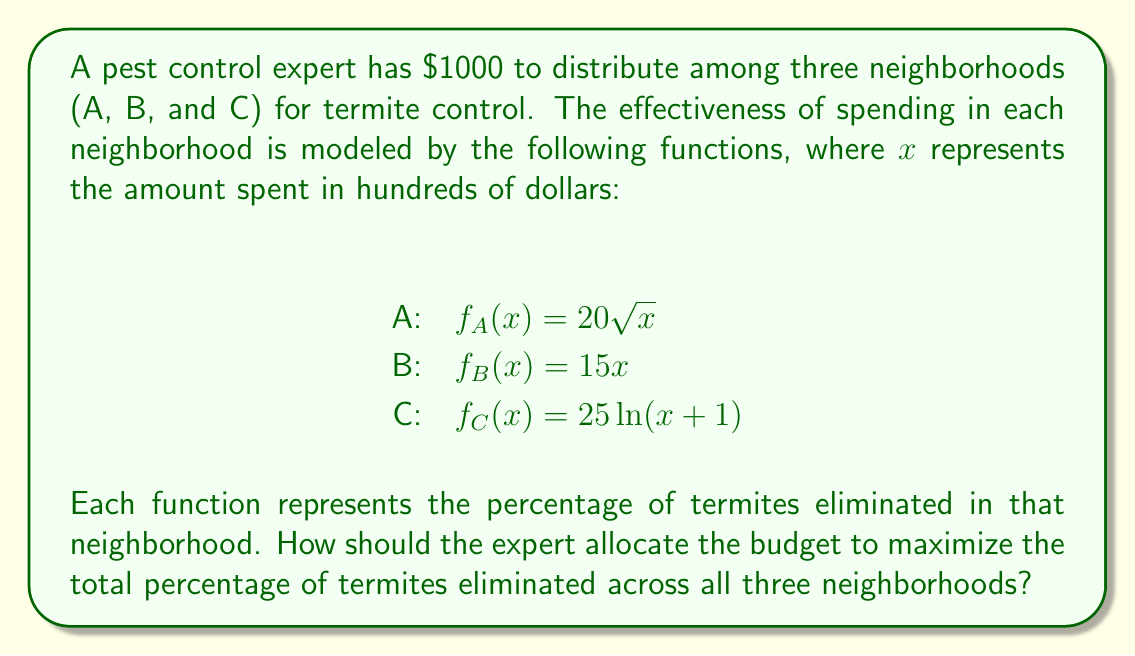Help me with this question. To solve this optimization problem, we need to use the method of Lagrange multipliers. Let's approach this step-by-step:

1) Let $x$, $y$, and $z$ represent the amount spent (in hundreds of dollars) in neighborhoods A, B, and C respectively.

2) Our objective function is:
   $$F(x,y,z) = 20\sqrt{x} + 15y + 25\ln(z+1)$$

3) Our constraint is:
   $$x + y + z = 10$$ (since the total budget is $1000 = 10 * $100)

4) We form the Lagrangian:
   $$L(x,y,z,\lambda) = 20\sqrt{x} + 15y + 25\ln(z+1) - \lambda(x + y + z - 10)$$

5) We now take partial derivatives and set them equal to zero:

   $$\frac{\partial L}{\partial x} = \frac{10}{\sqrt{x}} - \lambda = 0$$
   $$\frac{\partial L}{\partial y} = 15 - \lambda = 0$$
   $$\frac{\partial L}{\partial z} = \frac{25}{z+1} - \lambda = 0$$
   $$\frac{\partial L}{\partial \lambda} = x + y + z - 10 = 0$$

6) From these equations, we can deduce:

   $$\frac{10}{\sqrt{x}} = 15 = \frac{25}{z+1}$$

7) Solving these:
   $$x = (\frac{10}{15})^2 = \frac{4}{9} \approx 0.44$$
   $$y = 10 - x - z$$
   $$z = \frac{25}{15} - 1 = \frac{2}{3} \approx 0.67$$

8) Substituting the value of $z$ into the equation for $y$:
   $$y = 10 - 0.44 - 0.67 = 8.89$$

9) Converting back to actual dollar amounts:
   Neighborhood A: $44
   Neighborhood B: $889
   Neighborhood C: $67

10) We can verify that this sums to our total budget of $1000.
Answer: The optimal allocation is:
Neighborhood A: $44
Neighborhood B: $889
Neighborhood C: $67 